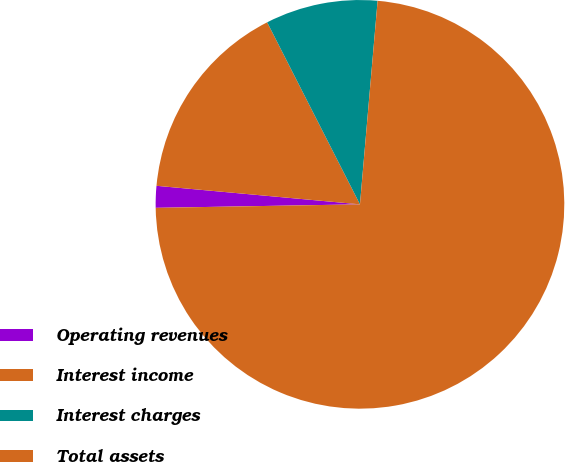<chart> <loc_0><loc_0><loc_500><loc_500><pie_chart><fcel>Operating revenues<fcel>Interest income<fcel>Interest charges<fcel>Total assets<nl><fcel>1.72%<fcel>16.05%<fcel>8.88%<fcel>73.35%<nl></chart> 